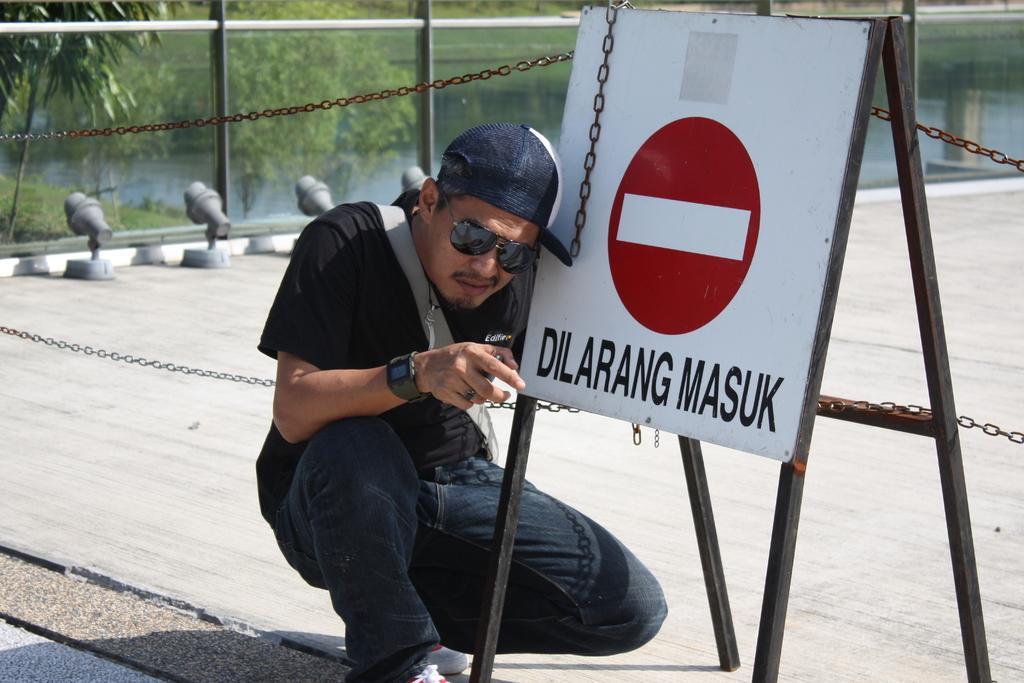Could you give a brief overview of what you see in this image? In this image, we can see a person wearing glasses, a cap and a bag and we can see a board with some text. In the background, there are trees, chains and there is water. At the bottom, there is a road. 